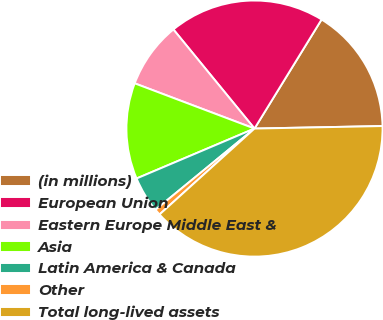Convert chart to OTSL. <chart><loc_0><loc_0><loc_500><loc_500><pie_chart><fcel>(in millions)<fcel>European Union<fcel>Eastern Europe Middle East &<fcel>Asia<fcel>Latin America & Canada<fcel>Other<fcel>Total long-lived assets<nl><fcel>15.91%<fcel>19.69%<fcel>8.34%<fcel>12.12%<fcel>4.56%<fcel>0.77%<fcel>38.61%<nl></chart> 